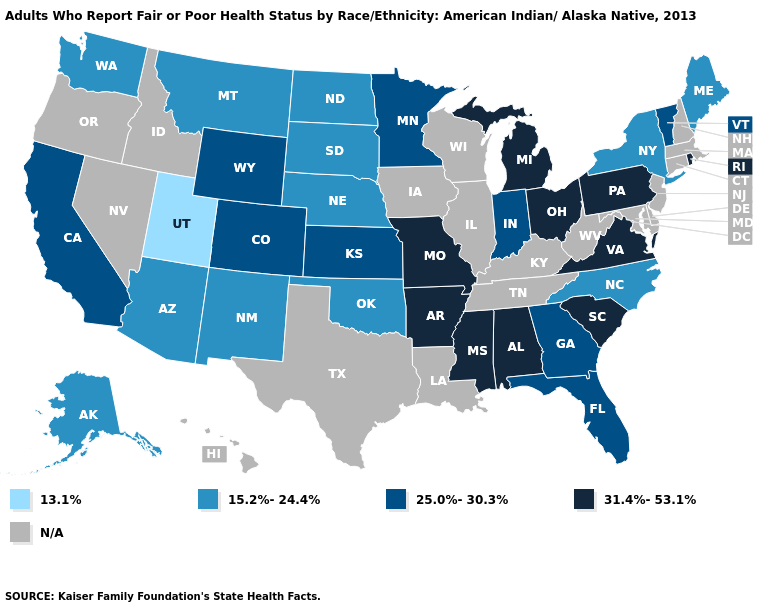Name the states that have a value in the range N/A?
Quick response, please. Connecticut, Delaware, Hawaii, Idaho, Illinois, Iowa, Kentucky, Louisiana, Maryland, Massachusetts, Nevada, New Hampshire, New Jersey, Oregon, Tennessee, Texas, West Virginia, Wisconsin. Name the states that have a value in the range 25.0%-30.3%?
Answer briefly. California, Colorado, Florida, Georgia, Indiana, Kansas, Minnesota, Vermont, Wyoming. What is the value of Kansas?
Give a very brief answer. 25.0%-30.3%. Name the states that have a value in the range 15.2%-24.4%?
Be succinct. Alaska, Arizona, Maine, Montana, Nebraska, New Mexico, New York, North Carolina, North Dakota, Oklahoma, South Dakota, Washington. What is the value of Ohio?
Keep it brief. 31.4%-53.1%. Does the first symbol in the legend represent the smallest category?
Give a very brief answer. Yes. What is the lowest value in states that border Wyoming?
Be succinct. 13.1%. Name the states that have a value in the range 25.0%-30.3%?
Write a very short answer. California, Colorado, Florida, Georgia, Indiana, Kansas, Minnesota, Vermont, Wyoming. Among the states that border Connecticut , does Rhode Island have the lowest value?
Keep it brief. No. Among the states that border Indiana , which have the lowest value?
Write a very short answer. Michigan, Ohio. Name the states that have a value in the range 13.1%?
Write a very short answer. Utah. What is the value of South Carolina?
Give a very brief answer. 31.4%-53.1%. What is the value of Louisiana?
Keep it brief. N/A. 